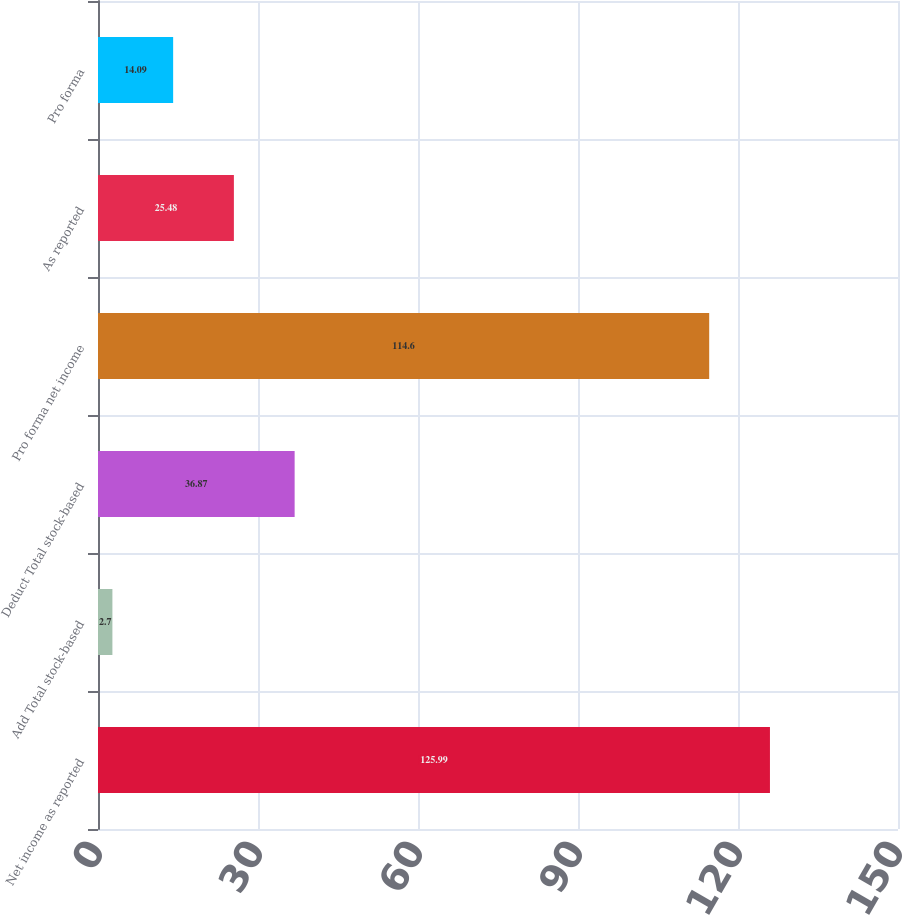<chart> <loc_0><loc_0><loc_500><loc_500><bar_chart><fcel>Net income as reported<fcel>Add Total stock-based<fcel>Deduct Total stock-based<fcel>Pro forma net income<fcel>As reported<fcel>Pro forma<nl><fcel>125.99<fcel>2.7<fcel>36.87<fcel>114.6<fcel>25.48<fcel>14.09<nl></chart> 